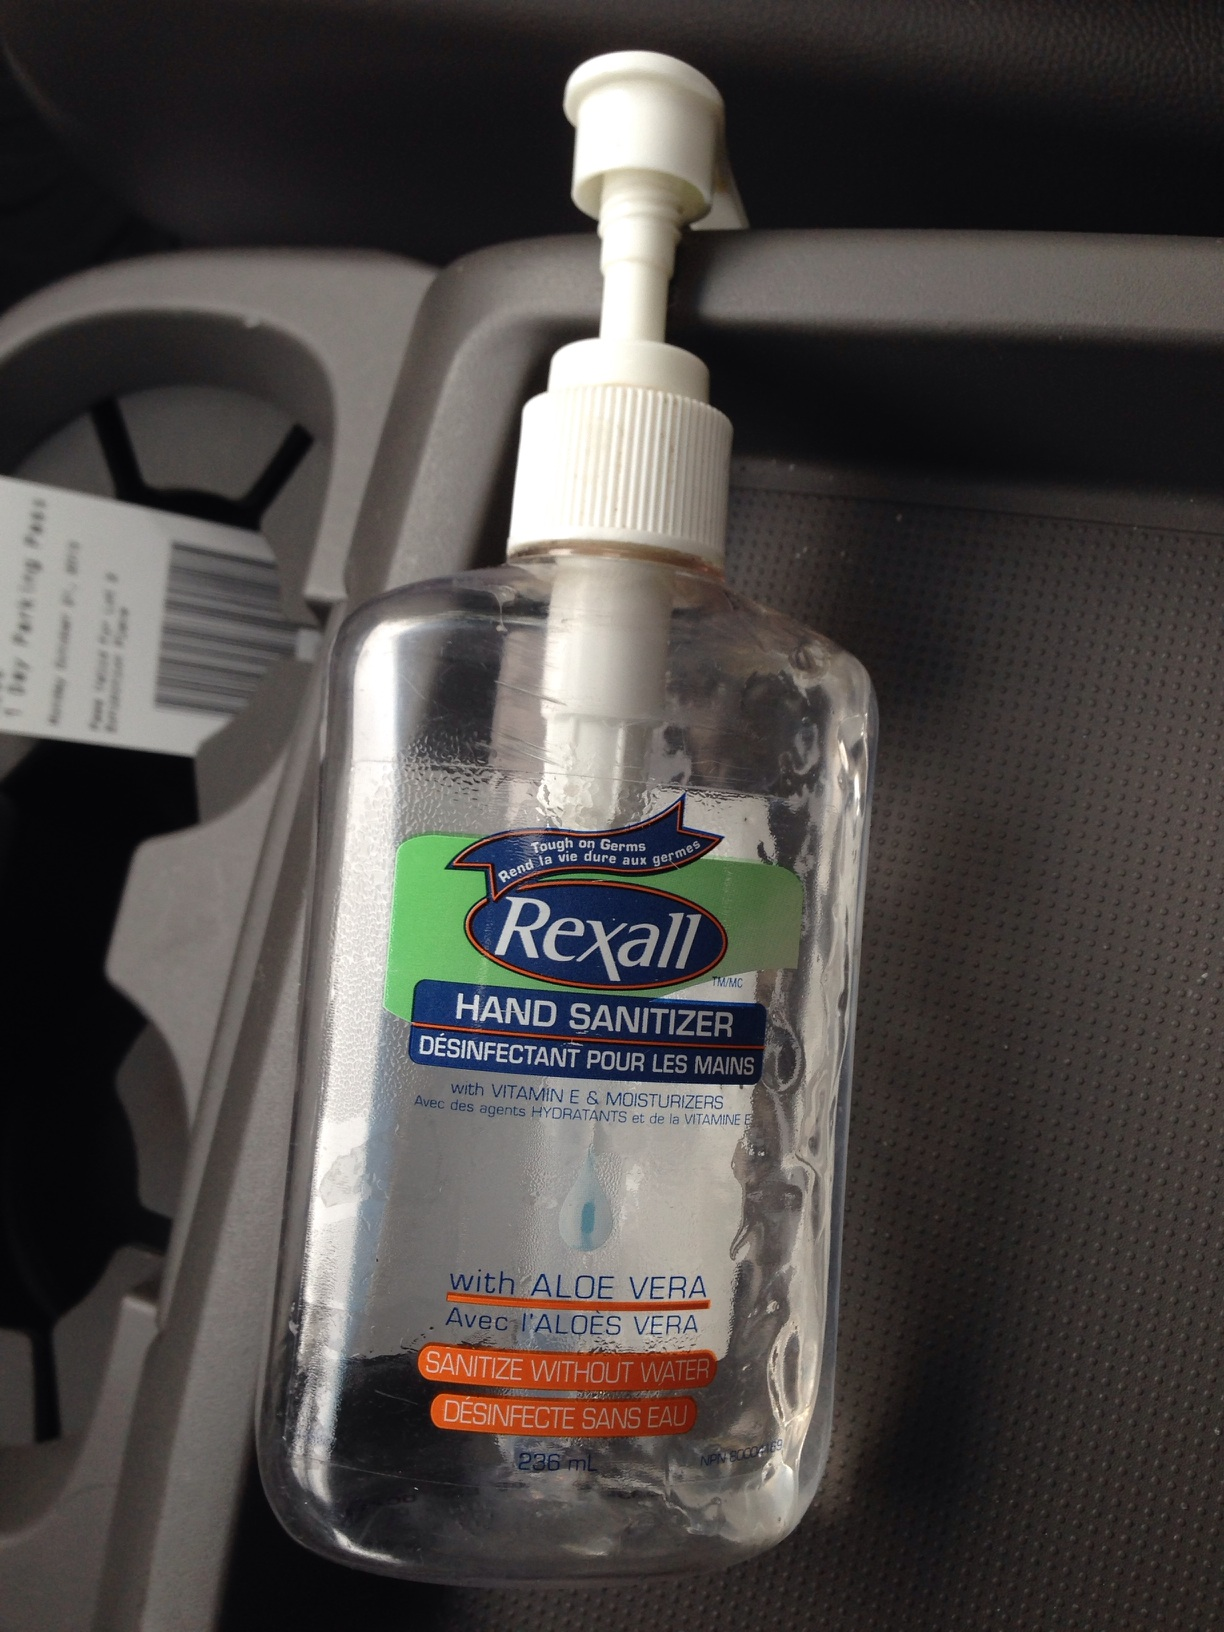Can you tell me more about the brand of this product? Rexall is a well-known pharmacy brand that provides a wide range of healthcare products, including over-the-counter medications and personal care items like this hand sanitizer. They are recognized for their commitment to affordable and accessible health solutions. 